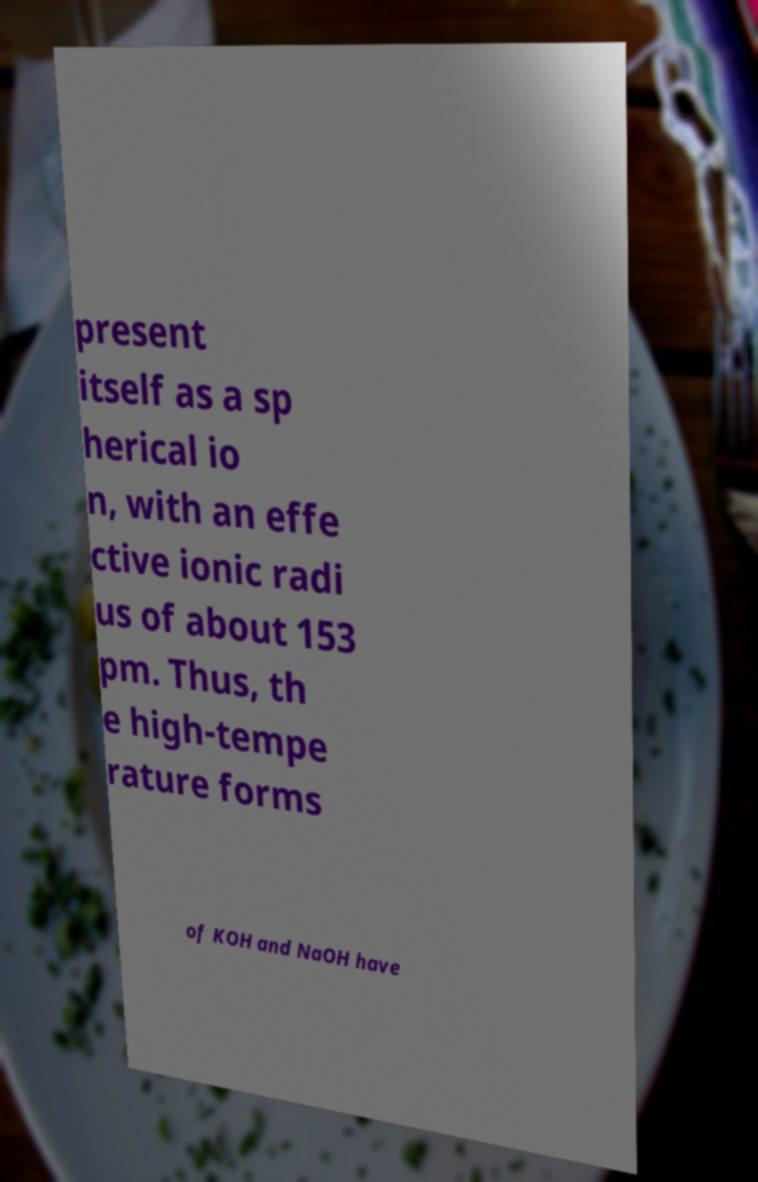There's text embedded in this image that I need extracted. Can you transcribe it verbatim? present itself as a sp herical io n, with an effe ctive ionic radi us of about 153 pm. Thus, th e high-tempe rature forms of KOH and NaOH have 